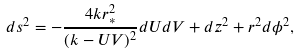Convert formula to latex. <formula><loc_0><loc_0><loc_500><loc_500>d s ^ { 2 } = - \frac { 4 k r _ { * } ^ { 2 } } { ( k - U V ) ^ { 2 } } d U d V + d z ^ { 2 } + r ^ { 2 } d \phi ^ { 2 } ,</formula> 